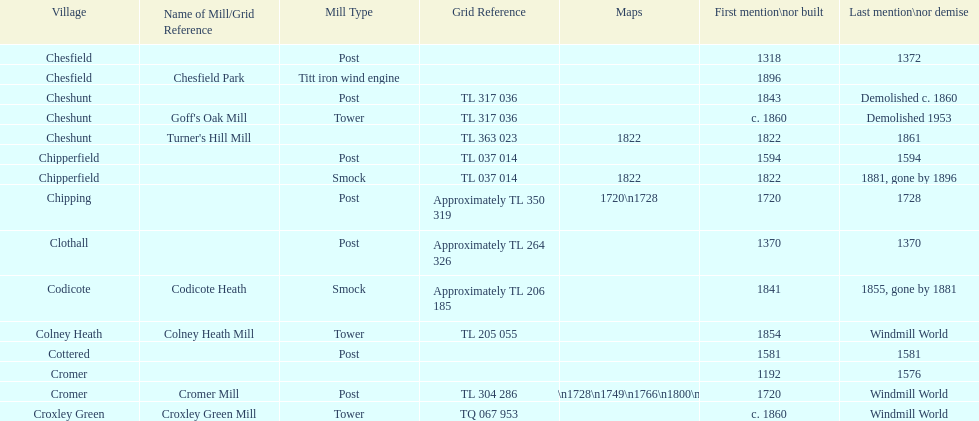Could you parse the entire table? {'header': ['Village', 'Name of Mill/Grid Reference', 'Mill Type', 'Grid Reference', 'Maps', 'First mention\\nor built', 'Last mention\\nor demise'], 'rows': [['Chesfield', '', 'Post', '', '', '1318', '1372'], ['Chesfield', 'Chesfield Park', 'Titt iron wind engine', '', '', '1896', ''], ['Cheshunt', '', 'Post', 'TL 317 036', '', '1843', 'Demolished c. 1860'], ['Cheshunt', "Goff's Oak Mill", 'Tower', 'TL 317 036', '', 'c. 1860', 'Demolished 1953'], ['Cheshunt', "Turner's Hill Mill", '', 'TL 363 023', '1822', '1822', '1861'], ['Chipperfield', '', 'Post', 'TL 037 014', '', '1594', '1594'], ['Chipperfield', '', 'Smock', 'TL 037 014', '1822', '1822', '1881, gone by 1896'], ['Chipping', '', 'Post', 'Approximately TL 350 319', '1720\\n1728', '1720', '1728'], ['Clothall', '', 'Post', 'Approximately TL 264 326', '', '1370', '1370'], ['Codicote', 'Codicote Heath', 'Smock', 'Approximately TL 206 185', '', '1841', '1855, gone by 1881'], ['Colney Heath', 'Colney Heath Mill', 'Tower', 'TL 205 055', '', '1854', 'Windmill World'], ['Cottered', '', 'Post', '', '', '1581', '1581'], ['Cromer', '', '', '', '', '1192', '1576'], ['Cromer', 'Cromer Mill', 'Post', 'TL 304 286', '1720\\n1728\\n1749\\n1766\\n1800\\n1822', '1720', 'Windmill World'], ['Croxley Green', 'Croxley Green Mill', 'Tower', 'TQ 067 953', '', 'c. 1860', 'Windmill World']]} Did cromer, chipperfield or cheshunt have the most windmills? Cheshunt. 